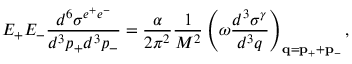<formula> <loc_0><loc_0><loc_500><loc_500>E _ { + } E _ { - } \frac { d ^ { 6 } \sigma ^ { e ^ { + } e ^ { - } } } { d ^ { 3 } p _ { + } d ^ { 3 } p _ { - } } = \frac { \alpha } { 2 \pi ^ { 2 } } \frac { 1 } { M ^ { 2 } } \left ( \omega \frac { d ^ { 3 } \sigma ^ { \gamma } } { d ^ { 3 } q } \right ) _ { { q } = { p } _ { + } + { p } _ { - } } ,</formula> 